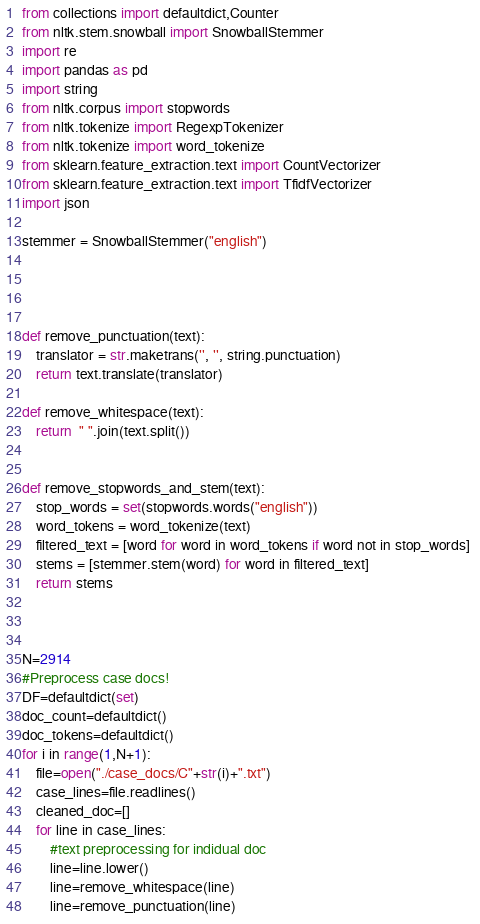<code> <loc_0><loc_0><loc_500><loc_500><_Python_>from collections import defaultdict,Counter
from nltk.stem.snowball import SnowballStemmer
import re
import pandas as pd
import string
from nltk.corpus import stopwords
from nltk.tokenize import RegexpTokenizer
from nltk.tokenize import word_tokenize 
from sklearn.feature_extraction.text import CountVectorizer 
from sklearn.feature_extraction.text import TfidfVectorizer 
import json

stemmer = SnowballStemmer("english")




def remove_punctuation(text):
    translator = str.maketrans('', '', string.punctuation) 
    return text.translate(translator)

def remove_whitespace(text): 
    return  " ".join(text.split()) 


def remove_stopwords_and_stem(text): 
    stop_words = set(stopwords.words("english")) 
    word_tokens = word_tokenize(text) 
    filtered_text = [word for word in word_tokens if word not in stop_words] 
    stems = [stemmer.stem(word) for word in filtered_text] 
    return stems
  


N=2914
#Preprocess case docs!
DF=defaultdict(set)
doc_count=defaultdict()
doc_tokens=defaultdict()
for i in range(1,N+1):
    file=open("./case_docs/C"+str(i)+".txt")
    case_lines=file.readlines()
    cleaned_doc=[]
    for line in case_lines:
        #text preprocessing for indidual doc
        line=line.lower() 
        line=remove_whitespace(line)
        line=remove_punctuation(line)</code> 